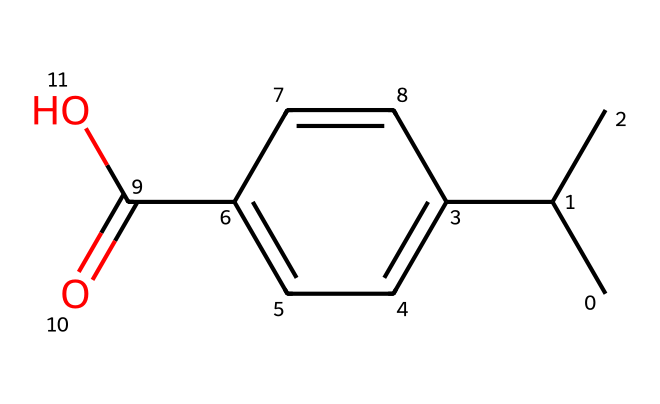How many carbon atoms are in the chemical structure? The SMILES representation shows multiple instances of "C" which represents carbon atoms. By counting, we can determine that there are 11 carbon atoms in total.
Answer: 11 What functional group is present in this chemical? The SMILES includes "C(=O)O," which indicates the presence of a carboxylic acid functional group, characterized by a carbon double-bonded to oxygen and also bonded to a hydroxyl group (-OH).
Answer: carboxylic acid Is this compound aromatic? The chemical structure features a ring with alternating double bonds (seen in the "C1=CC=C" part), indicating it follows Huckel's rule for aromaticity, thus confirming its aromatic nature.
Answer: yes What is the degree of unsaturation in this chemical? The presence of double bonds and rings (identified by counting the number of pi bonds and rings) indicates a degree of unsaturation. For this structure, the total degree of unsaturation is calculated to be 5.
Answer: 5 Does this chemical contain any heteroatoms? The SMILES does not contain elements other than carbon, hydrogen, and oxygen (C, H, O). Therefore, since there are no nitrogen, sulfur, or halogen atoms present, the answer is no heteroatoms.
Answer: no What type of chemical is this compound classified as? Since this chemical is used for insect repellent purposes, it would be classified as a natural insect repellent due to its biodegradable nature.
Answer: natural insect repellent 